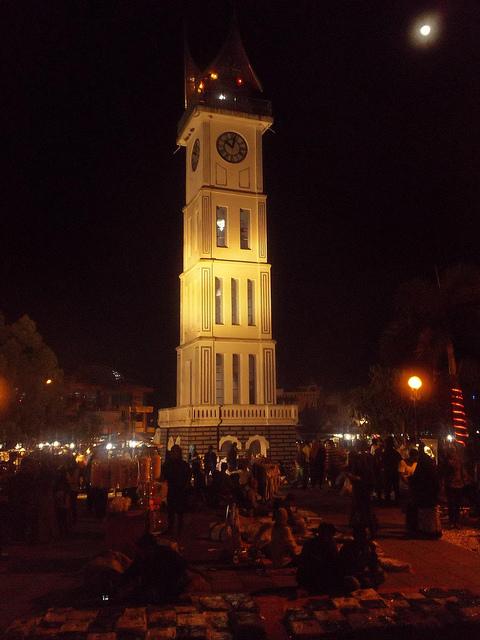Do people live in this structure?
Answer briefly. No. Where is the clock?
Keep it brief. On tower. Is this a place you would expect to find Taco Bell?
Be succinct. No. 